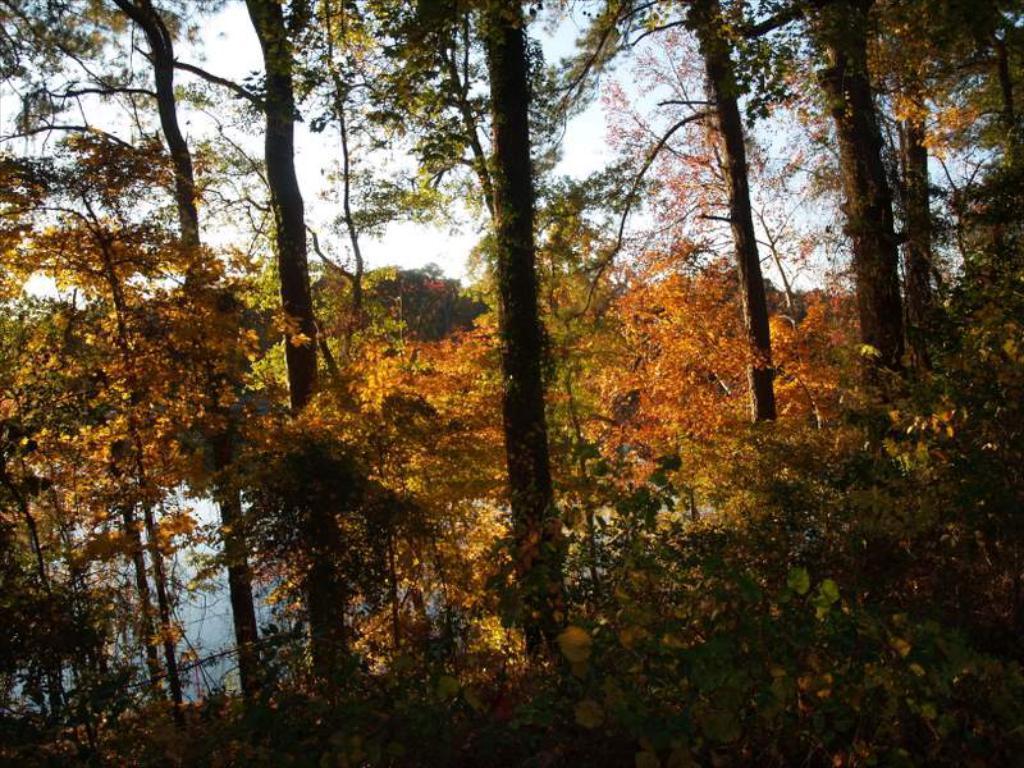Describe this image in one or two sentences. In this picture we can see many trees. On the bottom left there is a water. Here it's a sky and cloud. On the bottom we can see plants, grass and leaves. 